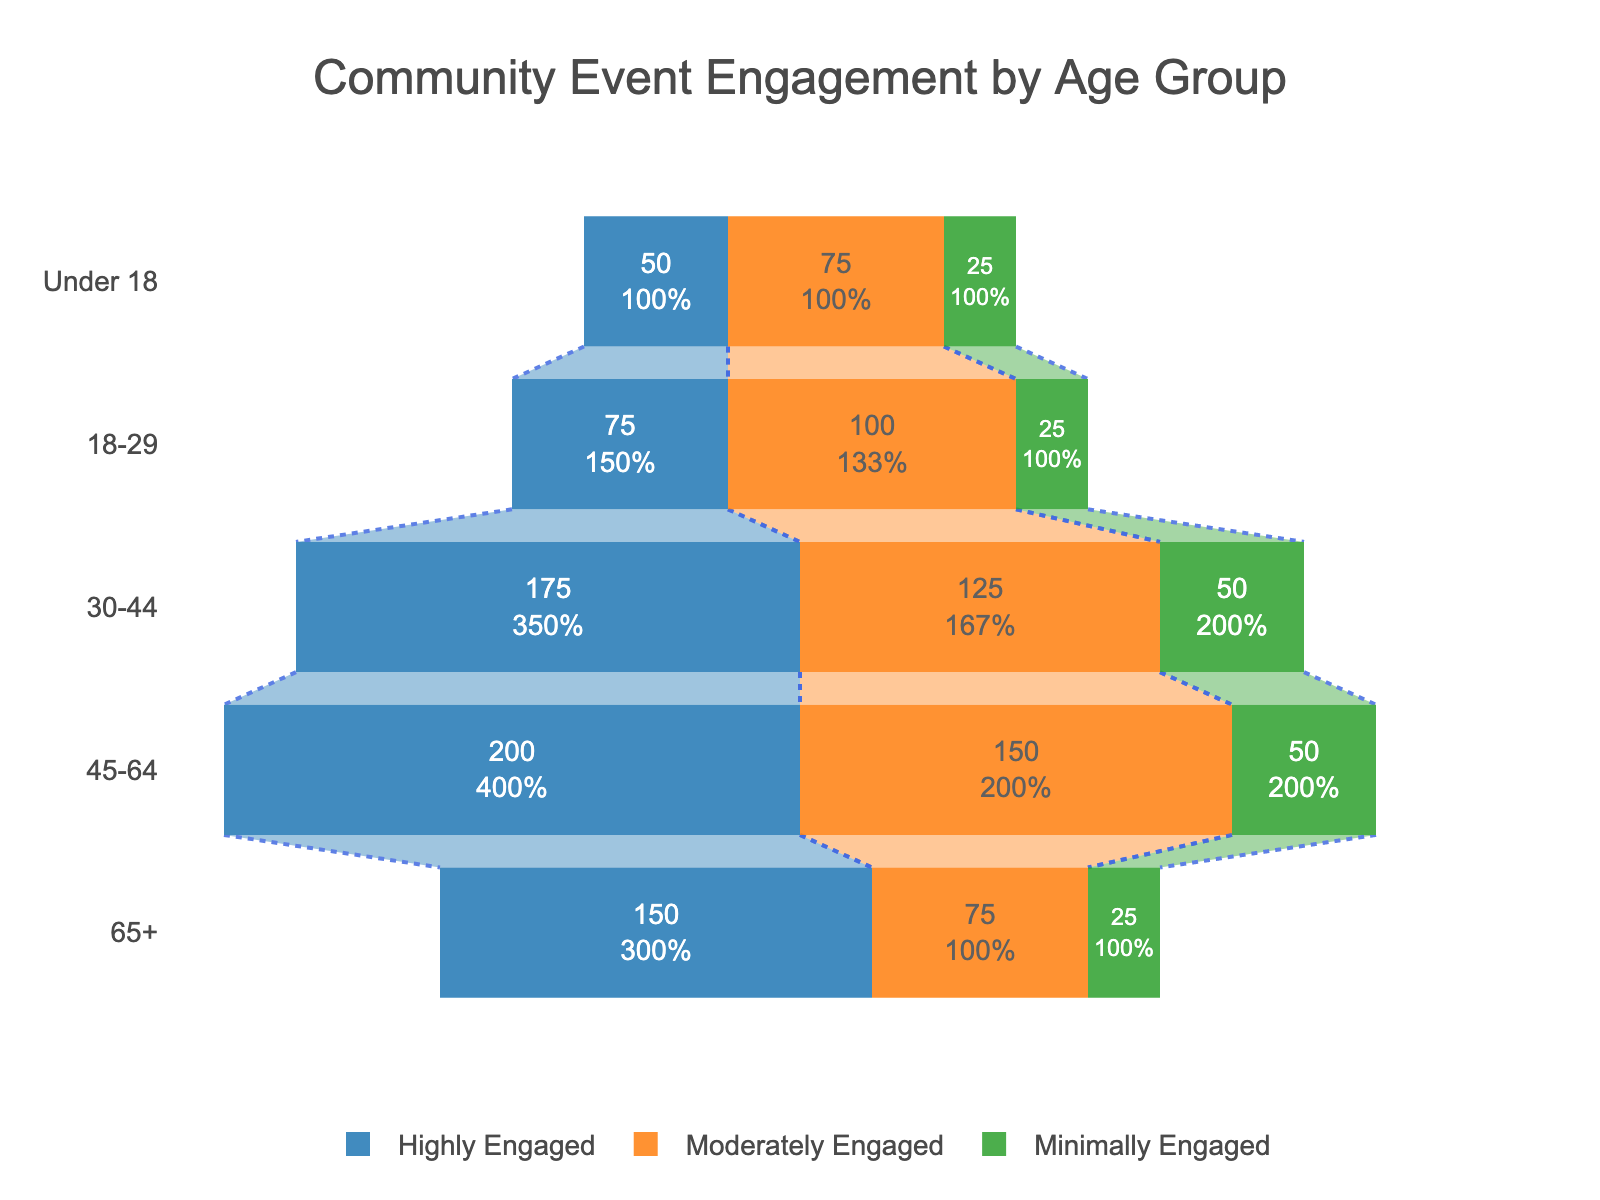What's the title of the figure? The title is typically placed at the top of the figure and describes the content of the chart. In this case, the title is "Community Event Engagement by Age Group."
Answer: Community Event Engagement by Age Group How many age groups are represented in the figure? By counting the distinct labels along the y-axis, we can see that there are five age groups: 65+, 45-64, 30-44, 18-29, and Under 18.
Answer: 5 Which age group has the highest number of highly engaged attendees? Look at the segments for "Highly Engaged" denoted by the blue color across different age groups. The age group with the largest segment is 65+ with 150 attendees.
Answer: 65+ How many more attendees are highly engaged in the 45-64 age group compared to the Under 18 age group? We need to subtract the number of highly engaged attendees in the Under 18 group (50) from that in the 45-64 group (200). So, 200 - 50 = 150.
Answer: 150 What is the total number of minimally engaged attendees across all age groups? Sum up the "Minimally Engaged" numbers for all the age groups: 25 (65+) + 50 (45-64) + 50 (30-44) + 25 (18-29) + 25 (Under 18). This gives us 25 + 50 + 50 + 25 + 25 = 175.
Answer: 175 Which age group has the smallest percentage of highly engaged attendees compared to their total number? Calculate the percentage of highly engaged attendees for each group and find the smallest. The percentages are: (150/250)*100 for 65+, (200/400)*100 for 45-64, (175/350)*100 for 30-44, (75/200)*100 for 18-29, and (50/150)*100 for Under 18. The smallest percentage is (75/200)*100 = 37.5% for the 18-29 age group.
Answer: 18-29 For the 30-44 age group, what is the ratio of highly engaged attendees to moderately engaged attendees? The number of highly engaged attendees in the 30-44 group is 175, and the number of moderately engaged is 125. Thus, the ratio is 175:125, which simplifies to 7:5.
Answer: 7:5 Compare the total number of attendees in the 18-29 age group to the 65+ age group. Which group has more attendees and by how much? The total attendees for 18-29 is 200 and for 65+ it is 250. Subtract the smaller value from the larger value: 250 - 200 = 50. The 65+ age group has more attendees by 50.
Answer: 65+, 50 What is the percentage of highly engaged attendees in the 45-64 age group out of the total attendees? Calculate the percentage by dividing the number of highly engaged attendees by the total attendees in the 45-64 age group and multiplying by 100. So, (200/400)*100 = 50%.
Answer: 50% Which two age groups have an equal number of minimally engaged attendees? Check the "Minimally Engaged" segments for all age groups. The 30-44 and 18-29 age groups both have 50 minimally engaged attendees.
Answer: 30-44 and 18-29 